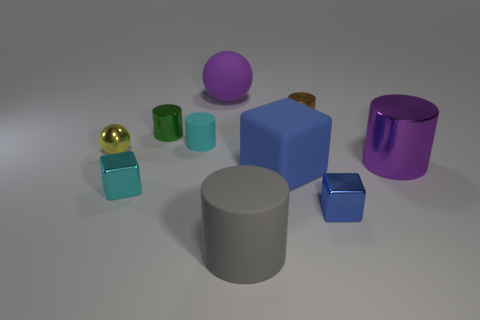Subtract 2 cylinders. How many cylinders are left? 3 Subtract all gray matte cylinders. How many cylinders are left? 4 Subtract all red cylinders. Subtract all purple cubes. How many cylinders are left? 5 Subtract all balls. How many objects are left? 8 Subtract all gray matte cylinders. Subtract all small yellow shiny balls. How many objects are left? 8 Add 6 blue matte objects. How many blue matte objects are left? 7 Add 5 small red metal spheres. How many small red metal spheres exist? 5 Subtract 0 brown spheres. How many objects are left? 10 